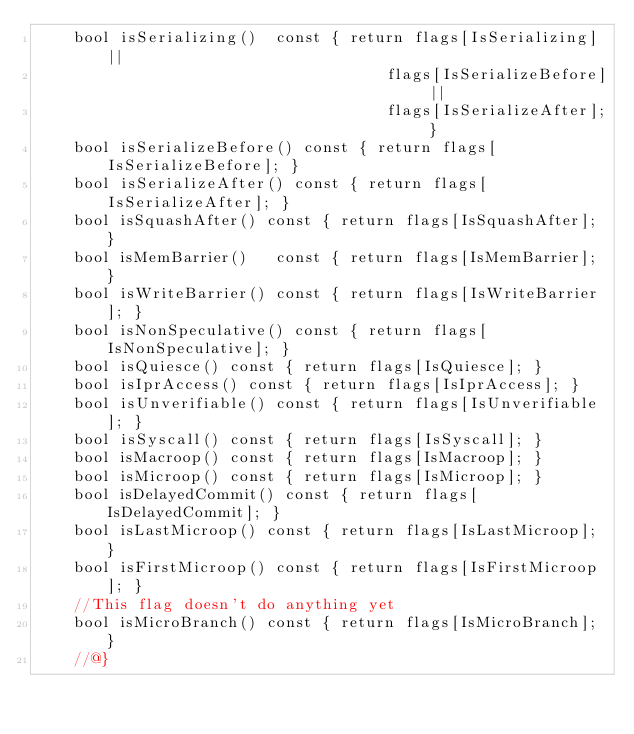Convert code to text. <code><loc_0><loc_0><loc_500><loc_500><_C++_>    bool isSerializing()  const { return flags[IsSerializing] ||
                                      flags[IsSerializeBefore] ||
                                      flags[IsSerializeAfter]; }
    bool isSerializeBefore() const { return flags[IsSerializeBefore]; }
    bool isSerializeAfter() const { return flags[IsSerializeAfter]; }
    bool isSquashAfter() const { return flags[IsSquashAfter]; }
    bool isMemBarrier()   const { return flags[IsMemBarrier]; }
    bool isWriteBarrier() const { return flags[IsWriteBarrier]; }
    bool isNonSpeculative() const { return flags[IsNonSpeculative]; }
    bool isQuiesce() const { return flags[IsQuiesce]; }
    bool isIprAccess() const { return flags[IsIprAccess]; }
    bool isUnverifiable() const { return flags[IsUnverifiable]; }
    bool isSyscall() const { return flags[IsSyscall]; }
    bool isMacroop() const { return flags[IsMacroop]; }
    bool isMicroop() const { return flags[IsMicroop]; }
    bool isDelayedCommit() const { return flags[IsDelayedCommit]; }
    bool isLastMicroop() const { return flags[IsLastMicroop]; }
    bool isFirstMicroop() const { return flags[IsFirstMicroop]; }
    //This flag doesn't do anything yet
    bool isMicroBranch() const { return flags[IsMicroBranch]; }
    //@}
</code> 